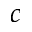Convert formula to latex. <formula><loc_0><loc_0><loc_500><loc_500>c</formula> 